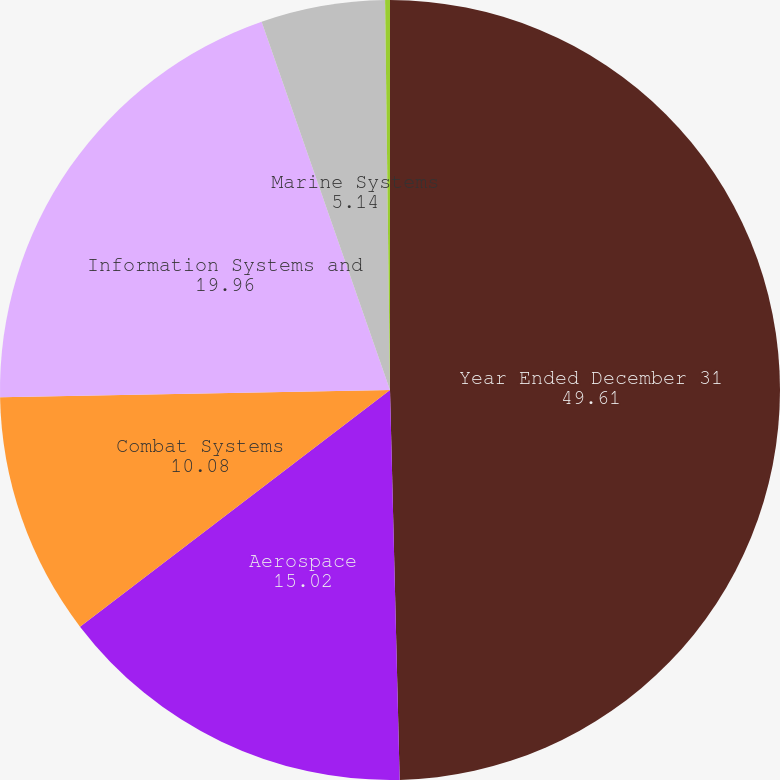Convert chart. <chart><loc_0><loc_0><loc_500><loc_500><pie_chart><fcel>Year Ended December 31<fcel>Aerospace<fcel>Combat Systems<fcel>Information Systems and<fcel>Marine Systems<fcel>Corporate (b)<nl><fcel>49.61%<fcel>15.02%<fcel>10.08%<fcel>19.96%<fcel>5.14%<fcel>0.2%<nl></chart> 